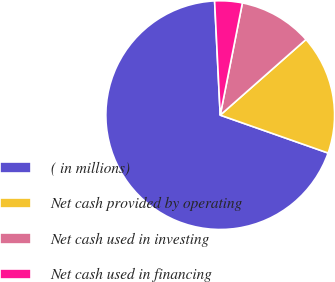<chart> <loc_0><loc_0><loc_500><loc_500><pie_chart><fcel>( in millions)<fcel>Net cash provided by operating<fcel>Net cash used in investing<fcel>Net cash used in financing<nl><fcel>68.84%<fcel>16.88%<fcel>10.39%<fcel>3.89%<nl></chart> 